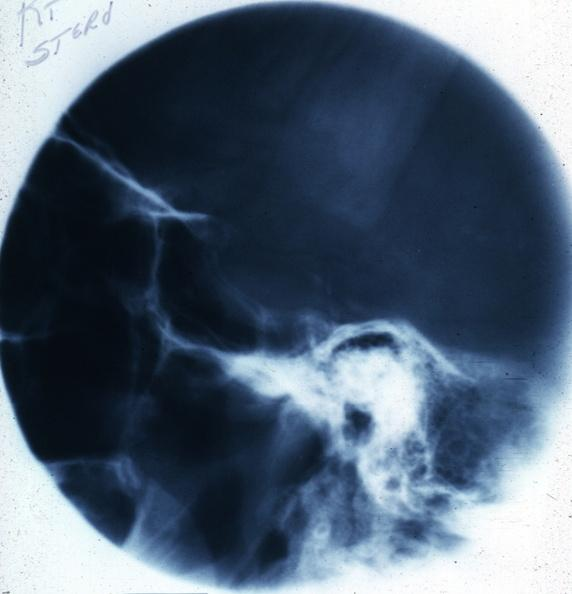s amyloidosis present?
Answer the question using a single word or phrase. No 